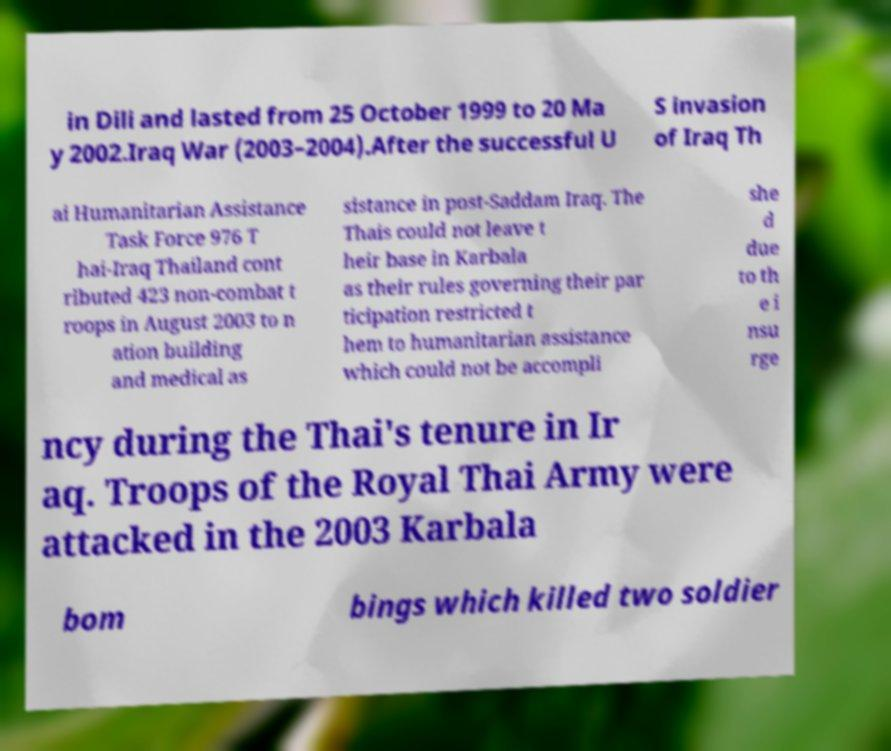For documentation purposes, I need the text within this image transcribed. Could you provide that? in Dili and lasted from 25 October 1999 to 20 Ma y 2002.Iraq War (2003–2004).After the successful U S invasion of Iraq Th ai Humanitarian Assistance Task Force 976 T hai-Iraq Thailand cont ributed 423 non-combat t roops in August 2003 to n ation building and medical as sistance in post-Saddam Iraq. The Thais could not leave t heir base in Karbala as their rules governing their par ticipation restricted t hem to humanitarian assistance which could not be accompli she d due to th e i nsu rge ncy during the Thai's tenure in Ir aq. Troops of the Royal Thai Army were attacked in the 2003 Karbala bom bings which killed two soldier 